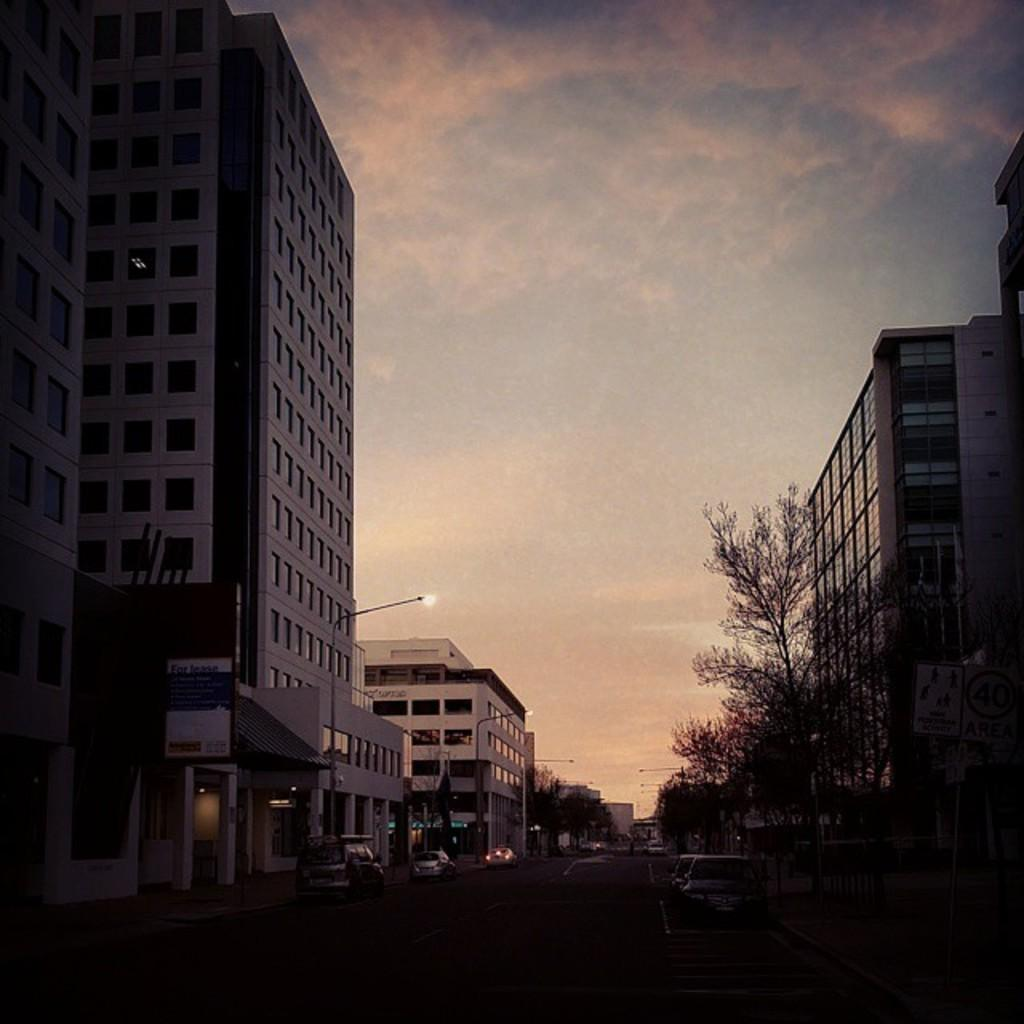What type of vehicles can be seen on the road in the image? There are cars on the road in the image. What structures are present alongside the road? There are light poles on either side of the road. What type of vegetation is present alongside the road? Trees are present on either side of the road. What type of structures can be seen in the image? Buildings are visible in the image. What is visible in the background of the image? The sky is visible in the background of the image. Can you tell me how many books are stacked on the quicksand in the image? There is no quicksand or books present in the image. 